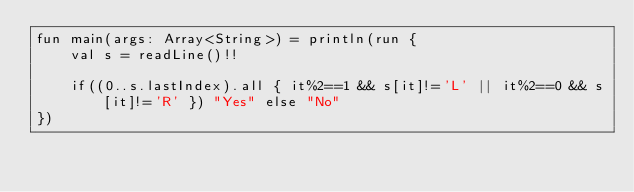Convert code to text. <code><loc_0><loc_0><loc_500><loc_500><_Kotlin_>fun main(args: Array<String>) = println(run {
    val s = readLine()!!

    if((0..s.lastIndex).all { it%2==1 && s[it]!='L' || it%2==0 && s[it]!='R' }) "Yes" else "No"
})</code> 